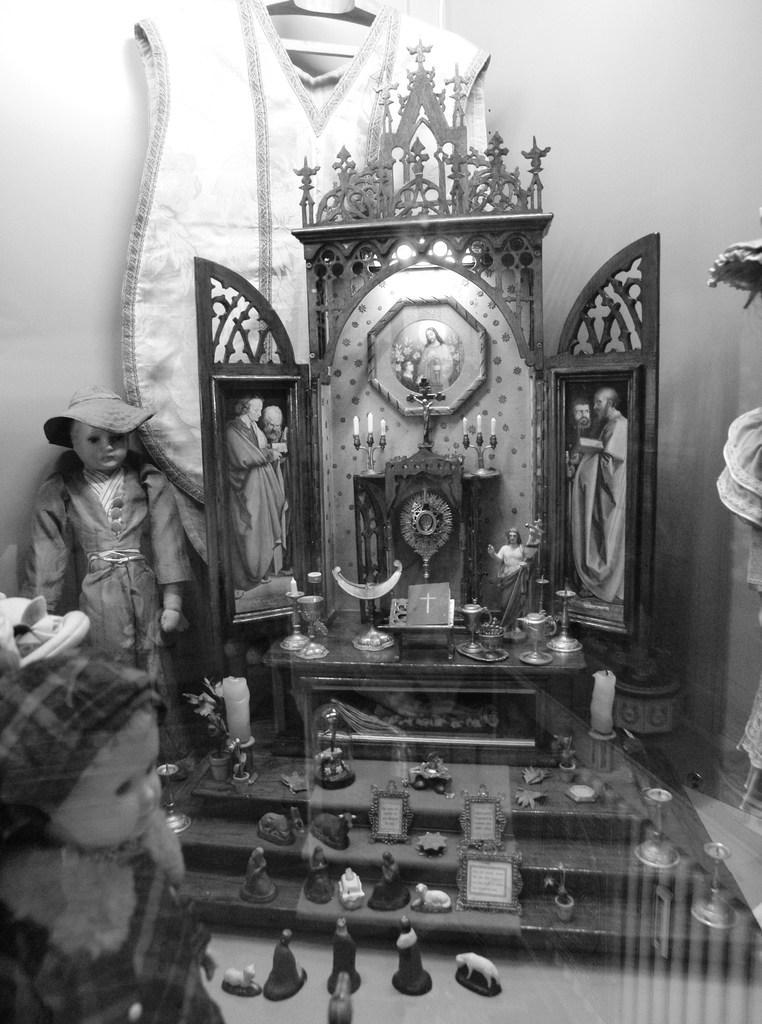In one or two sentences, can you explain what this image depicts? This is a black and white image which is clicked inside. In the foreground we can see there are some items placed on the stairs of a cabinet and we can see the pictures of some persons and there is a candle stand with the candles. On the left we can see the dolls. In the background there is a wall and some clothes hanging on the wall. 